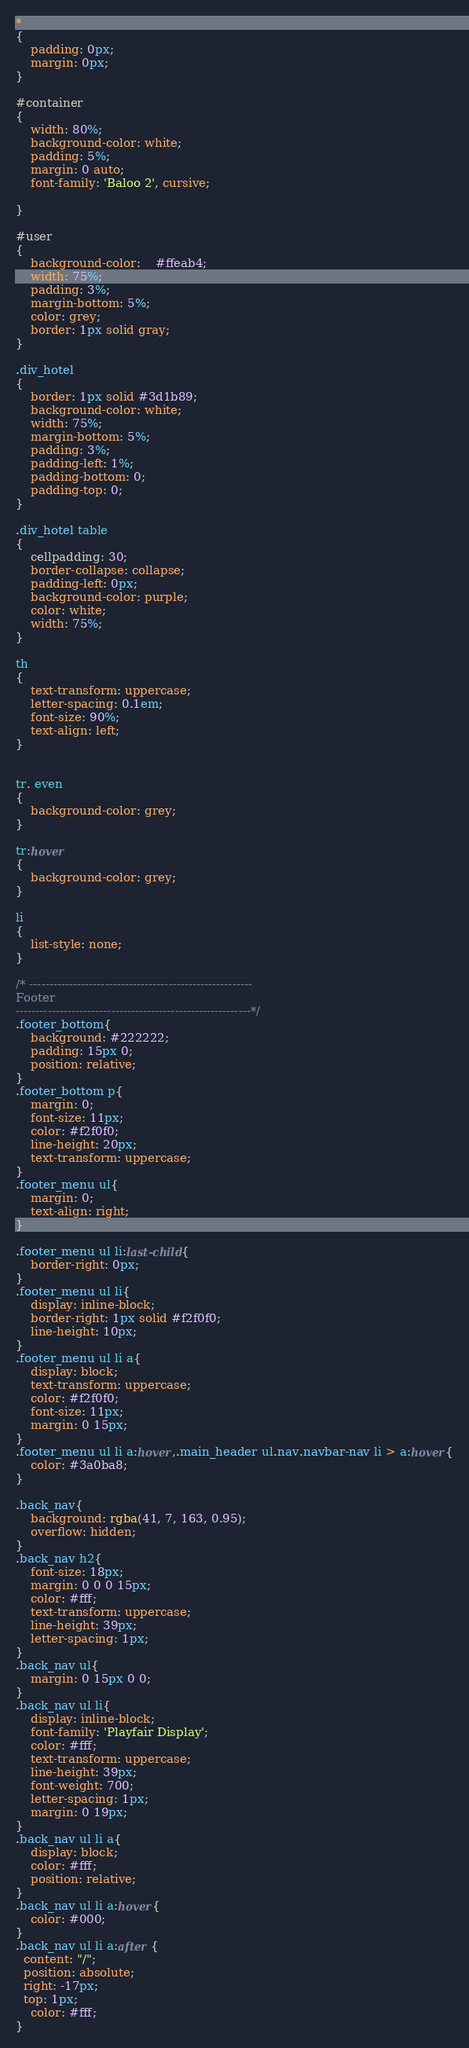Convert code to text. <code><loc_0><loc_0><loc_500><loc_500><_CSS_>*
{
    padding: 0px;
    margin: 0px;
}

#container
{
    width: 80%;
    background-color: white;
    padding: 5%;
	margin: 0 auto;
	font-family: 'Baloo 2', cursive;
	
}

#user
{
	background-color: 	#ffeab4;
	width: 75%;
	padding: 3%;
	margin-bottom: 5%;
	color: grey;
	border: 1px solid gray;
}

.div_hotel
{
	border: 1px solid #3d1b89;
	background-color: white;
	width: 75%;
	margin-bottom: 5%;
	padding: 3%;
	padding-left: 1%;
	padding-bottom: 0;
	padding-top: 0;
}

.div_hotel table
{
	cellpadding: 30;
	border-collapse: collapse;
	padding-left: 0px;
	background-color: purple;
	color: white;
	width: 75%;
}

th
{
	text-transform: uppercase;
	letter-spacing: 0.1em;
	font-size: 90%;
	text-align: left;
}

		
tr. even
{
	background-color: grey;
}		
		
tr:hover
{
	background-color: grey;
}

li
{
	list-style: none;
}

/* --------------------------------------------------------
Footer
-----------------------------------------------------------*/
.footer_bottom{
    background: #222222;
    padding: 15px 0;
    position: relative;
}
.footer_bottom p{
    margin: 0;
    font-size: 11px;
    color: #f2f0f0;
    line-height: 20px;
    text-transform: uppercase;
}
.footer_menu ul{
    margin: 0;
    text-align: right;
}

.footer_menu ul li:last-child{
    border-right: 0px;
}
.footer_menu ul li{
    display: inline-block;
    border-right: 1px solid #f2f0f0;
    line-height: 10px;
}
.footer_menu ul li a{
    display: block;
    text-transform: uppercase;
    color: #f2f0f0;
    font-size: 11px;
    margin: 0 15px;
}
.footer_menu ul li a:hover,.main_header ul.nav.navbar-nav li > a:hover{
    color: #3a0ba8;
}

.back_nav{
    background: rgba(41, 7, 163, 0.95);
    overflow: hidden;
}
.back_nav h2{
    font-size: 18px;
    margin: 0 0 0 15px;
    color: #fff;
    text-transform: uppercase;
    line-height: 39px;
    letter-spacing: 1px;
}
.back_nav ul{
    margin: 0 15px 0 0;
}
.back_nav ul li{
    display: inline-block;
    font-family: 'Playfair Display';
    color: #fff;
    text-transform: uppercase;
    line-height: 39px;
    font-weight: 700;
    letter-spacing: 1px;
    margin: 0 19px;
}
.back_nav ul li a{
    display: block;
    color: #fff;
    position: relative;
}
.back_nav ul li a:hover{
    color: #000;
}
.back_nav ul li a:after {
  content: "/";
  position: absolute;
  right: -17px;
  top: 1px;
    color: #fff;
}</code> 